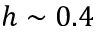Convert formula to latex. <formula><loc_0><loc_0><loc_500><loc_500>h \sim 0 . 4</formula> 